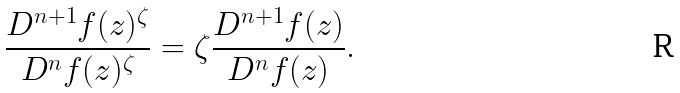<formula> <loc_0><loc_0><loc_500><loc_500>\frac { D ^ { n + 1 } f ( z ) ^ { \zeta } } { D ^ { n } f ( z ) ^ { \zeta } } = \zeta \frac { D ^ { n + 1 } f ( z ) } { D ^ { n } f ( z ) } . \,</formula> 